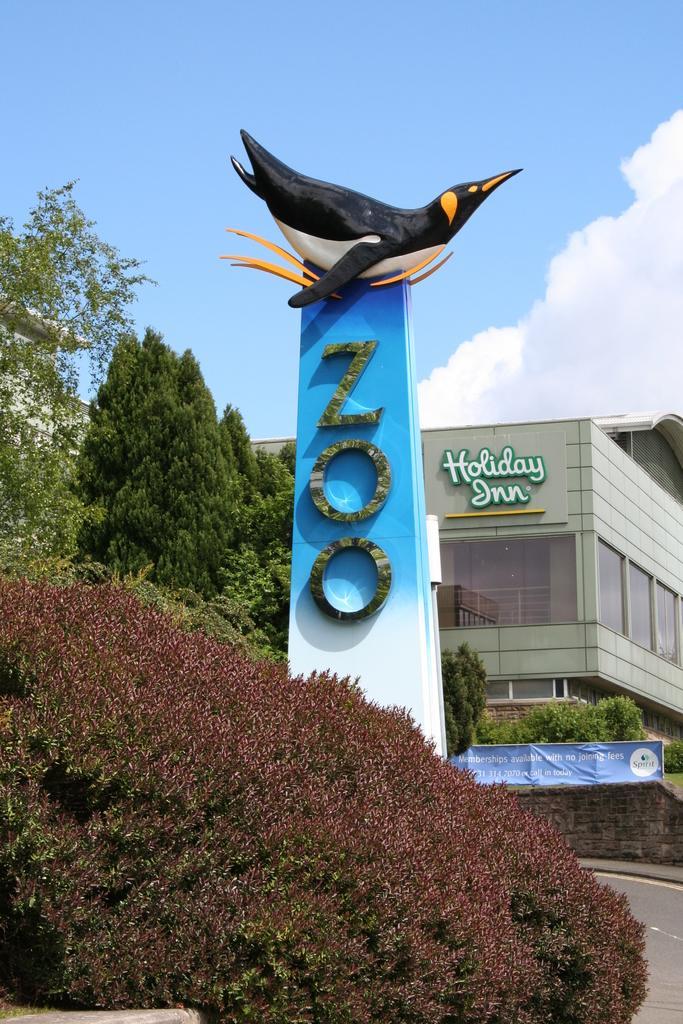How would you summarize this image in a sentence or two? In this image we can see a zoo memorial. In the background there is a building. Image also consists of many trees and shrubs. At the top there is sky with clouds. 